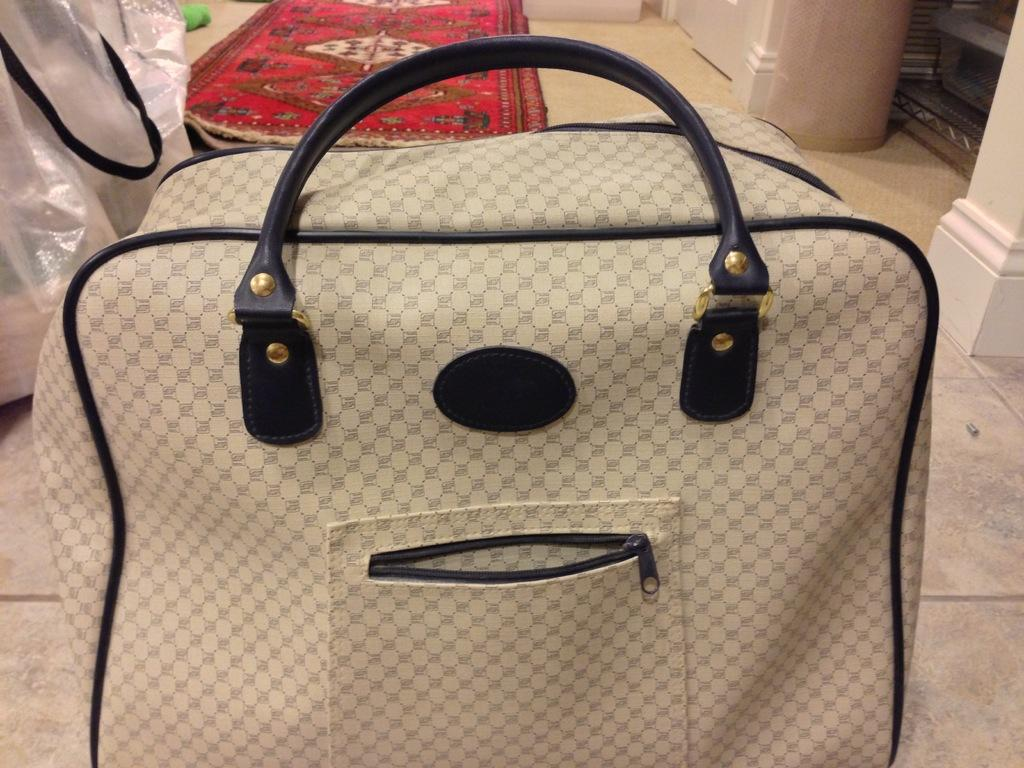What is the main subject in the center of the image? There is a handbag in the center of the image. Are there any other bags visible in the image? Yes, there is another bag beside the handbag. What type of flooring can be seen in the background of the image? There is a red carpet on the floor in the background of the image. How many cows are present in the image? There are no cows present in the image; it features handbags and a red carpet. What type of crime is being committed in the image? There is no crime being committed in the image; it is a simple image of handbags and a red carpet. 